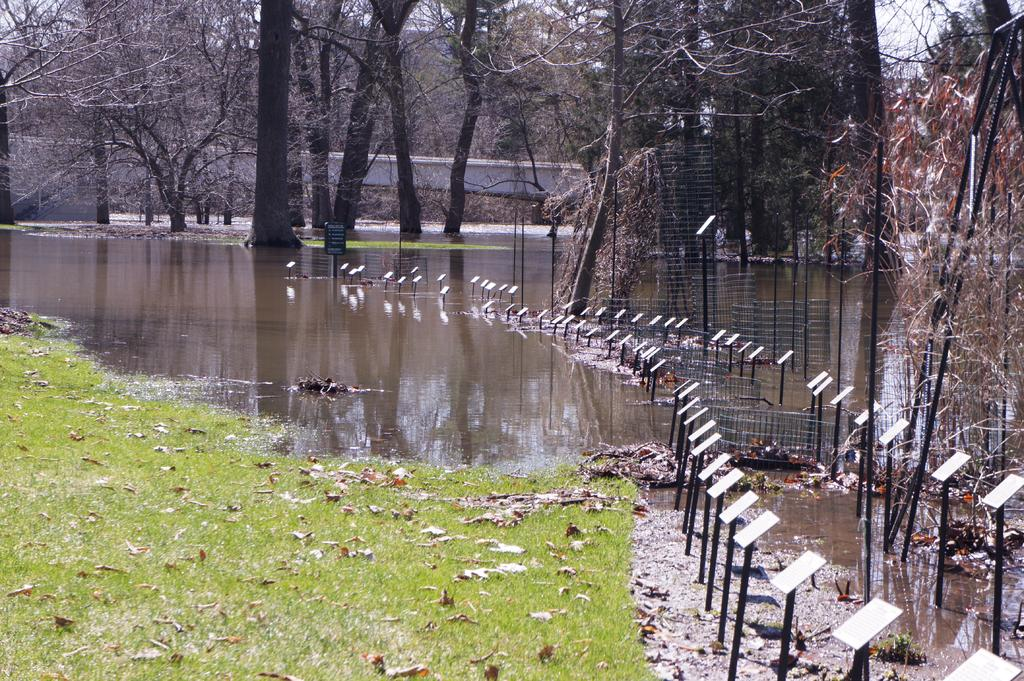What type of vegetation can be seen on the ground in the image? There are dry leaves on the grassy land in the image. What body of water is present in the image? There is a lake in the image. What type of energy-generating equipment is visible in the image? Solar panels are present in the image. What type of structure is present in the image to separate areas? There is a mesh in the image. What type of barrier is visible in the image? A boundary wall is visible in the image. What type of natural feature is present in the image? Trees are present in the image. What is visible at the top of the image? The sky is visible at the top of the image. How many ants can be seen carrying leaves in the image? There are no ants present in the image, and therefore no such activity can be observed. What type of learning material is visible in the image? There is no learning material present in the image. 